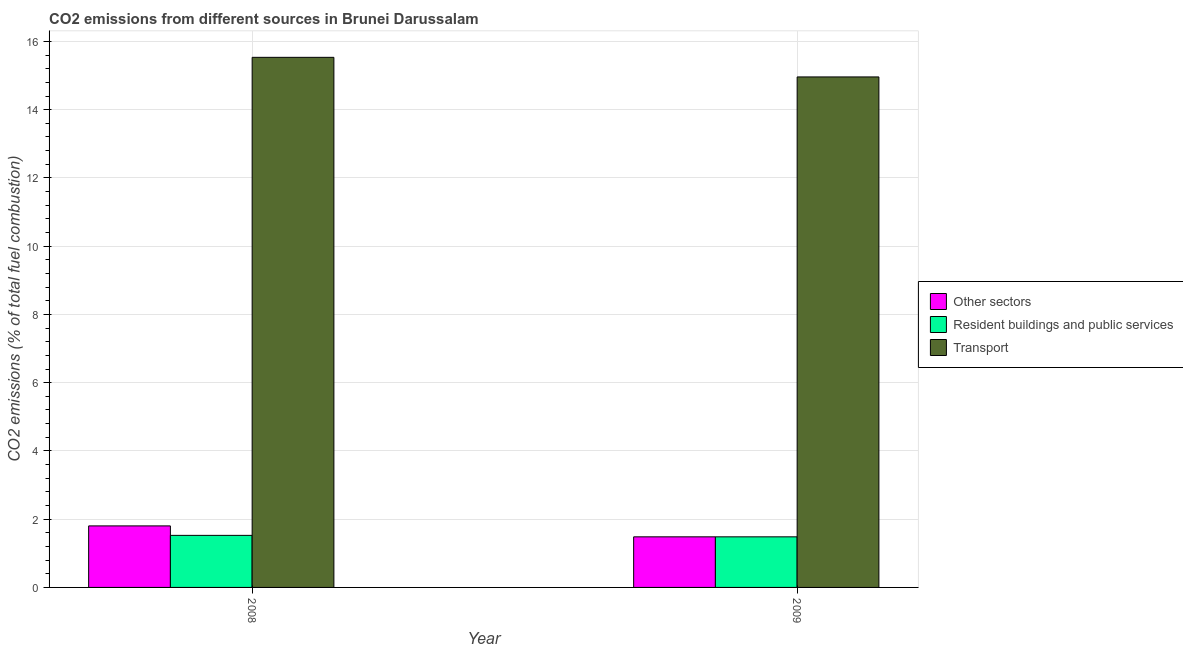How many different coloured bars are there?
Give a very brief answer. 3. Are the number of bars on each tick of the X-axis equal?
Ensure brevity in your answer.  Yes. How many bars are there on the 1st tick from the right?
Keep it short and to the point. 3. What is the label of the 2nd group of bars from the left?
Provide a succinct answer. 2009. In how many cases, is the number of bars for a given year not equal to the number of legend labels?
Provide a succinct answer. 0. What is the percentage of co2 emissions from transport in 2009?
Provide a short and direct response. 14.96. Across all years, what is the maximum percentage of co2 emissions from transport?
Keep it short and to the point. 15.53. Across all years, what is the minimum percentage of co2 emissions from resident buildings and public services?
Your response must be concise. 1.48. What is the total percentage of co2 emissions from other sectors in the graph?
Make the answer very short. 3.29. What is the difference between the percentage of co2 emissions from transport in 2008 and that in 2009?
Offer a terse response. 0.57. What is the difference between the percentage of co2 emissions from transport in 2008 and the percentage of co2 emissions from other sectors in 2009?
Ensure brevity in your answer.  0.57. What is the average percentage of co2 emissions from transport per year?
Your response must be concise. 15.25. In how many years, is the percentage of co2 emissions from other sectors greater than 14.8 %?
Ensure brevity in your answer.  0. What is the ratio of the percentage of co2 emissions from other sectors in 2008 to that in 2009?
Provide a succinct answer. 1.22. In how many years, is the percentage of co2 emissions from other sectors greater than the average percentage of co2 emissions from other sectors taken over all years?
Your response must be concise. 1. What does the 2nd bar from the left in 2009 represents?
Offer a very short reply. Resident buildings and public services. What does the 1st bar from the right in 2009 represents?
Your answer should be compact. Transport. Where does the legend appear in the graph?
Your response must be concise. Center right. How are the legend labels stacked?
Provide a short and direct response. Vertical. What is the title of the graph?
Provide a succinct answer. CO2 emissions from different sources in Brunei Darussalam. What is the label or title of the X-axis?
Ensure brevity in your answer.  Year. What is the label or title of the Y-axis?
Provide a succinct answer. CO2 emissions (% of total fuel combustion). What is the CO2 emissions (% of total fuel combustion) of Other sectors in 2008?
Make the answer very short. 1.8. What is the CO2 emissions (% of total fuel combustion) in Resident buildings and public services in 2008?
Provide a short and direct response. 1.53. What is the CO2 emissions (% of total fuel combustion) in Transport in 2008?
Make the answer very short. 15.53. What is the CO2 emissions (% of total fuel combustion) in Other sectors in 2009?
Make the answer very short. 1.48. What is the CO2 emissions (% of total fuel combustion) of Resident buildings and public services in 2009?
Provide a short and direct response. 1.48. What is the CO2 emissions (% of total fuel combustion) of Transport in 2009?
Your response must be concise. 14.96. Across all years, what is the maximum CO2 emissions (% of total fuel combustion) of Other sectors?
Your response must be concise. 1.8. Across all years, what is the maximum CO2 emissions (% of total fuel combustion) of Resident buildings and public services?
Offer a terse response. 1.53. Across all years, what is the maximum CO2 emissions (% of total fuel combustion) of Transport?
Give a very brief answer. 15.53. Across all years, what is the minimum CO2 emissions (% of total fuel combustion) in Other sectors?
Make the answer very short. 1.48. Across all years, what is the minimum CO2 emissions (% of total fuel combustion) in Resident buildings and public services?
Make the answer very short. 1.48. Across all years, what is the minimum CO2 emissions (% of total fuel combustion) in Transport?
Provide a short and direct response. 14.96. What is the total CO2 emissions (% of total fuel combustion) in Other sectors in the graph?
Your answer should be very brief. 3.29. What is the total CO2 emissions (% of total fuel combustion) in Resident buildings and public services in the graph?
Your answer should be compact. 3.01. What is the total CO2 emissions (% of total fuel combustion) of Transport in the graph?
Keep it short and to the point. 30.49. What is the difference between the CO2 emissions (% of total fuel combustion) in Other sectors in 2008 and that in 2009?
Your answer should be compact. 0.32. What is the difference between the CO2 emissions (% of total fuel combustion) of Resident buildings and public services in 2008 and that in 2009?
Provide a short and direct response. 0.04. What is the difference between the CO2 emissions (% of total fuel combustion) of Transport in 2008 and that in 2009?
Keep it short and to the point. 0.57. What is the difference between the CO2 emissions (% of total fuel combustion) of Other sectors in 2008 and the CO2 emissions (% of total fuel combustion) of Resident buildings and public services in 2009?
Provide a succinct answer. 0.32. What is the difference between the CO2 emissions (% of total fuel combustion) in Other sectors in 2008 and the CO2 emissions (% of total fuel combustion) in Transport in 2009?
Your answer should be very brief. -13.16. What is the difference between the CO2 emissions (% of total fuel combustion) in Resident buildings and public services in 2008 and the CO2 emissions (% of total fuel combustion) in Transport in 2009?
Make the answer very short. -13.43. What is the average CO2 emissions (% of total fuel combustion) of Other sectors per year?
Provide a short and direct response. 1.64. What is the average CO2 emissions (% of total fuel combustion) of Resident buildings and public services per year?
Give a very brief answer. 1.5. What is the average CO2 emissions (% of total fuel combustion) in Transport per year?
Offer a terse response. 15.25. In the year 2008, what is the difference between the CO2 emissions (% of total fuel combustion) of Other sectors and CO2 emissions (% of total fuel combustion) of Resident buildings and public services?
Provide a short and direct response. 0.28. In the year 2008, what is the difference between the CO2 emissions (% of total fuel combustion) in Other sectors and CO2 emissions (% of total fuel combustion) in Transport?
Provide a succinct answer. -13.73. In the year 2008, what is the difference between the CO2 emissions (% of total fuel combustion) in Resident buildings and public services and CO2 emissions (% of total fuel combustion) in Transport?
Your answer should be very brief. -14.01. In the year 2009, what is the difference between the CO2 emissions (% of total fuel combustion) of Other sectors and CO2 emissions (% of total fuel combustion) of Transport?
Offer a very short reply. -13.48. In the year 2009, what is the difference between the CO2 emissions (% of total fuel combustion) in Resident buildings and public services and CO2 emissions (% of total fuel combustion) in Transport?
Give a very brief answer. -13.48. What is the ratio of the CO2 emissions (% of total fuel combustion) in Other sectors in 2008 to that in 2009?
Offer a terse response. 1.22. What is the ratio of the CO2 emissions (% of total fuel combustion) in Resident buildings and public services in 2008 to that in 2009?
Offer a terse response. 1.03. What is the ratio of the CO2 emissions (% of total fuel combustion) in Transport in 2008 to that in 2009?
Offer a terse response. 1.04. What is the difference between the highest and the second highest CO2 emissions (% of total fuel combustion) of Other sectors?
Provide a short and direct response. 0.32. What is the difference between the highest and the second highest CO2 emissions (% of total fuel combustion) of Resident buildings and public services?
Ensure brevity in your answer.  0.04. What is the difference between the highest and the second highest CO2 emissions (% of total fuel combustion) in Transport?
Offer a very short reply. 0.57. What is the difference between the highest and the lowest CO2 emissions (% of total fuel combustion) in Other sectors?
Make the answer very short. 0.32. What is the difference between the highest and the lowest CO2 emissions (% of total fuel combustion) of Resident buildings and public services?
Offer a very short reply. 0.04. What is the difference between the highest and the lowest CO2 emissions (% of total fuel combustion) in Transport?
Your response must be concise. 0.57. 